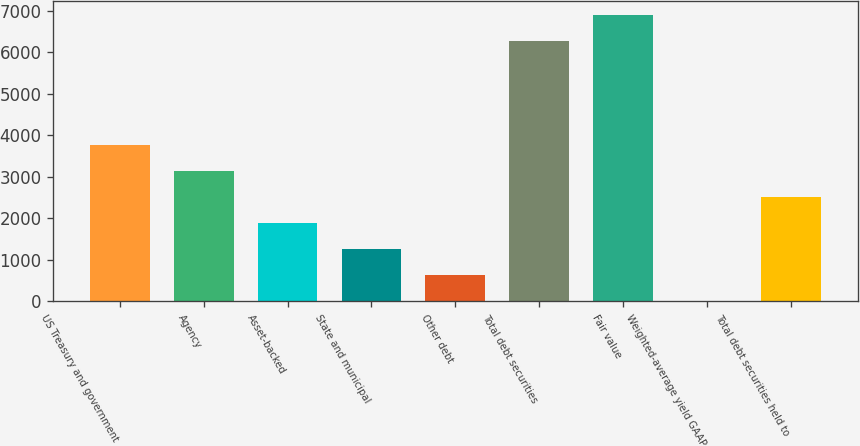Convert chart to OTSL. <chart><loc_0><loc_0><loc_500><loc_500><bar_chart><fcel>US Treasury and government<fcel>Agency<fcel>Asset-backed<fcel>State and municipal<fcel>Other debt<fcel>Total debt securities<fcel>Fair value<fcel>Weighted-average yield GAAP<fcel>Total debt securities held to<nl><fcel>3771.31<fcel>3143.38<fcel>1887.53<fcel>1259.61<fcel>631.68<fcel>6271<fcel>6898.93<fcel>3.75<fcel>2515.45<nl></chart> 